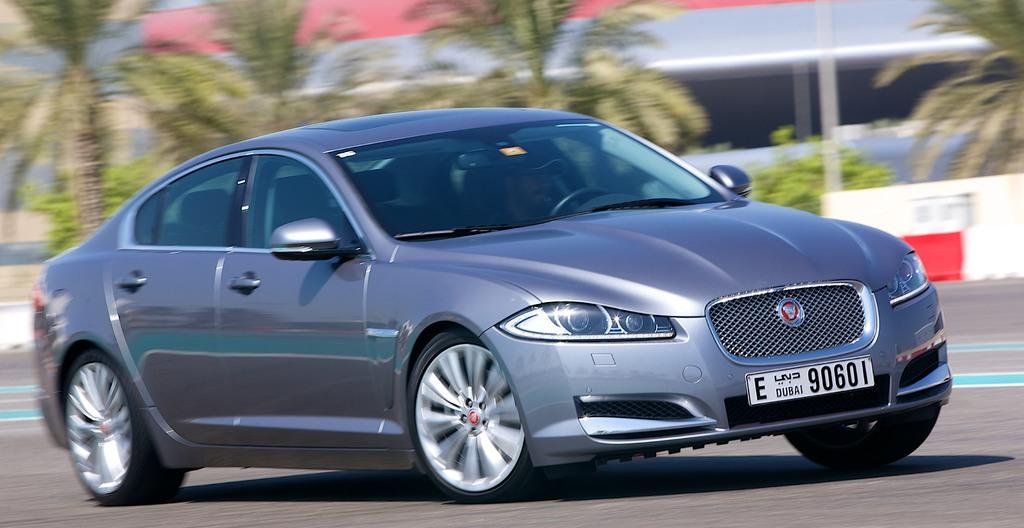What is the main subject of the image? The main subject of the image is a car on the road. What can be seen in the background of the image? There are trees visible in the background of the image. What type of disease is affecting the leather in the image? There is no leather or disease present in the image; it features a car on the road and trees in the background. 